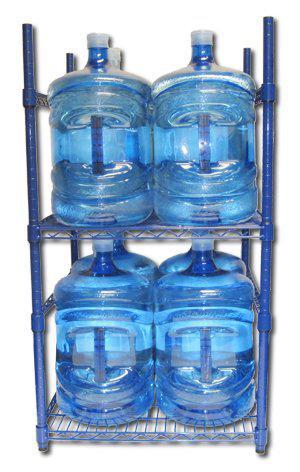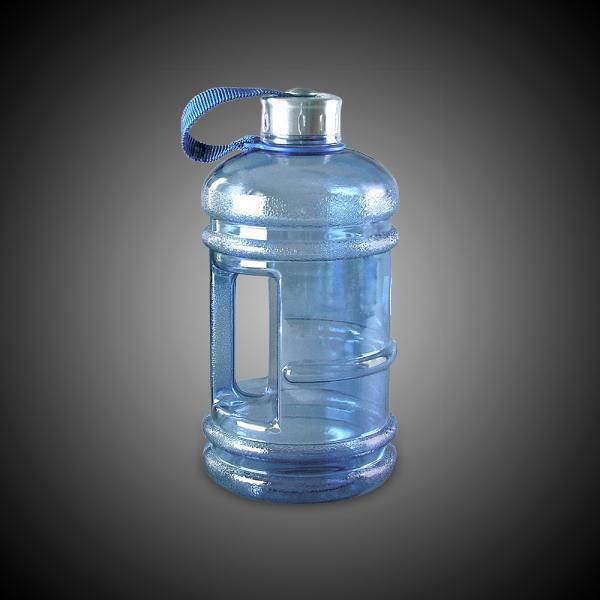The first image is the image on the left, the second image is the image on the right. Evaluate the accuracy of this statement regarding the images: "Large blue bottles in one image have clear caps and a side hand grip.". Is it true? Answer yes or no. Yes. The first image is the image on the left, the second image is the image on the right. Assess this claim about the two images: "An image shows at least one water bottle with a loop handle on the lid.". Correct or not? Answer yes or no. Yes. 